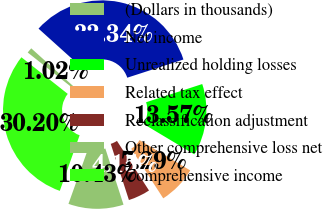Convert chart to OTSL. <chart><loc_0><loc_0><loc_500><loc_500><pie_chart><fcel>(Dollars in thousands)<fcel>Net income<fcel>Unrealized holding losses<fcel>Related tax effect<fcel>Reclassification adjustment<fcel>Other comprehensive loss net<fcel>Comprehensive income<nl><fcel>1.02%<fcel>33.34%<fcel>13.57%<fcel>7.29%<fcel>4.15%<fcel>10.43%<fcel>30.2%<nl></chart> 